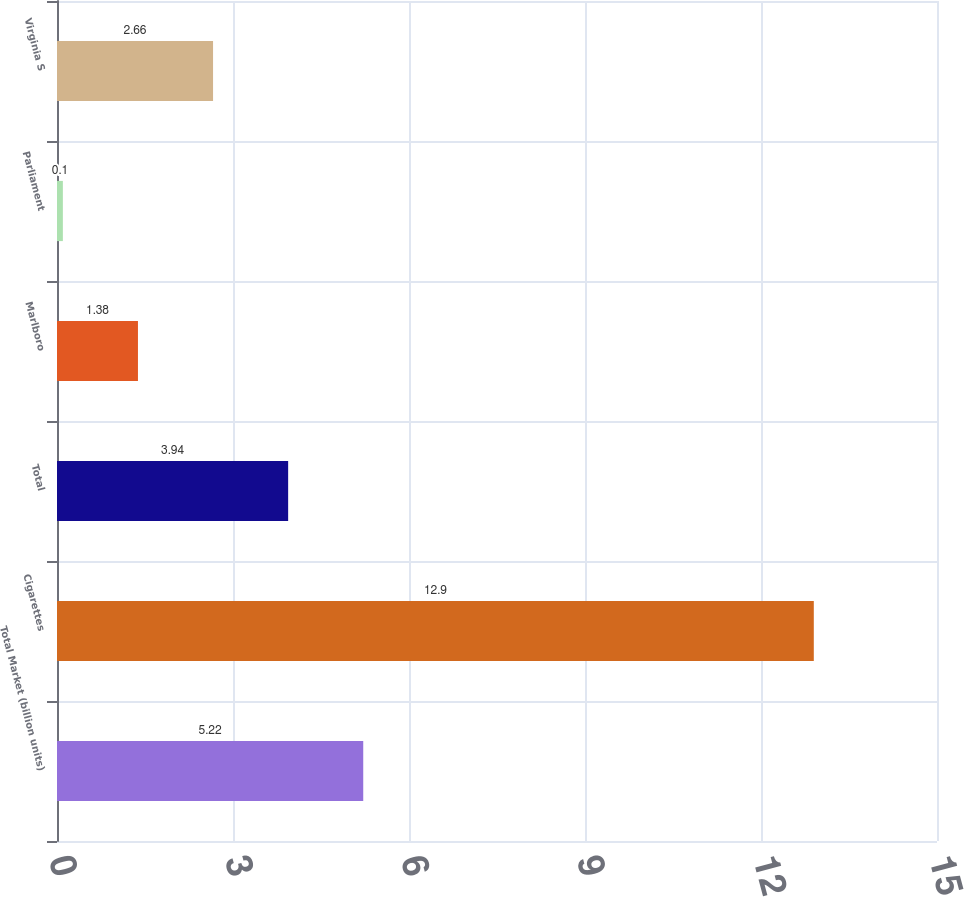Convert chart. <chart><loc_0><loc_0><loc_500><loc_500><bar_chart><fcel>Total Market (billion units)<fcel>Cigarettes<fcel>Total<fcel>Marlboro<fcel>Parliament<fcel>Virginia S<nl><fcel>5.22<fcel>12.9<fcel>3.94<fcel>1.38<fcel>0.1<fcel>2.66<nl></chart> 